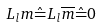Convert formula to latex. <formula><loc_0><loc_0><loc_500><loc_500>L _ { l } m \hat { = } L _ { l } \overline { m } \hat { = } 0</formula> 